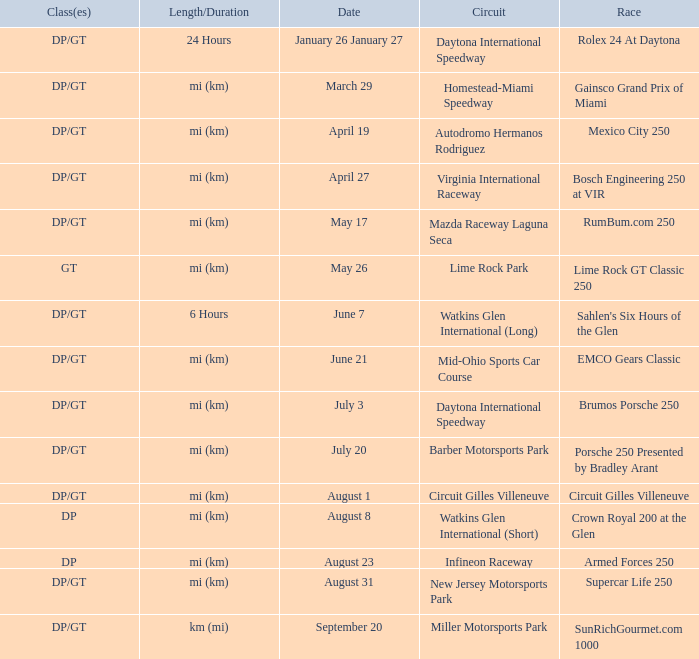What was the circuit had a race on September 20. Miller Motorsports Park. 